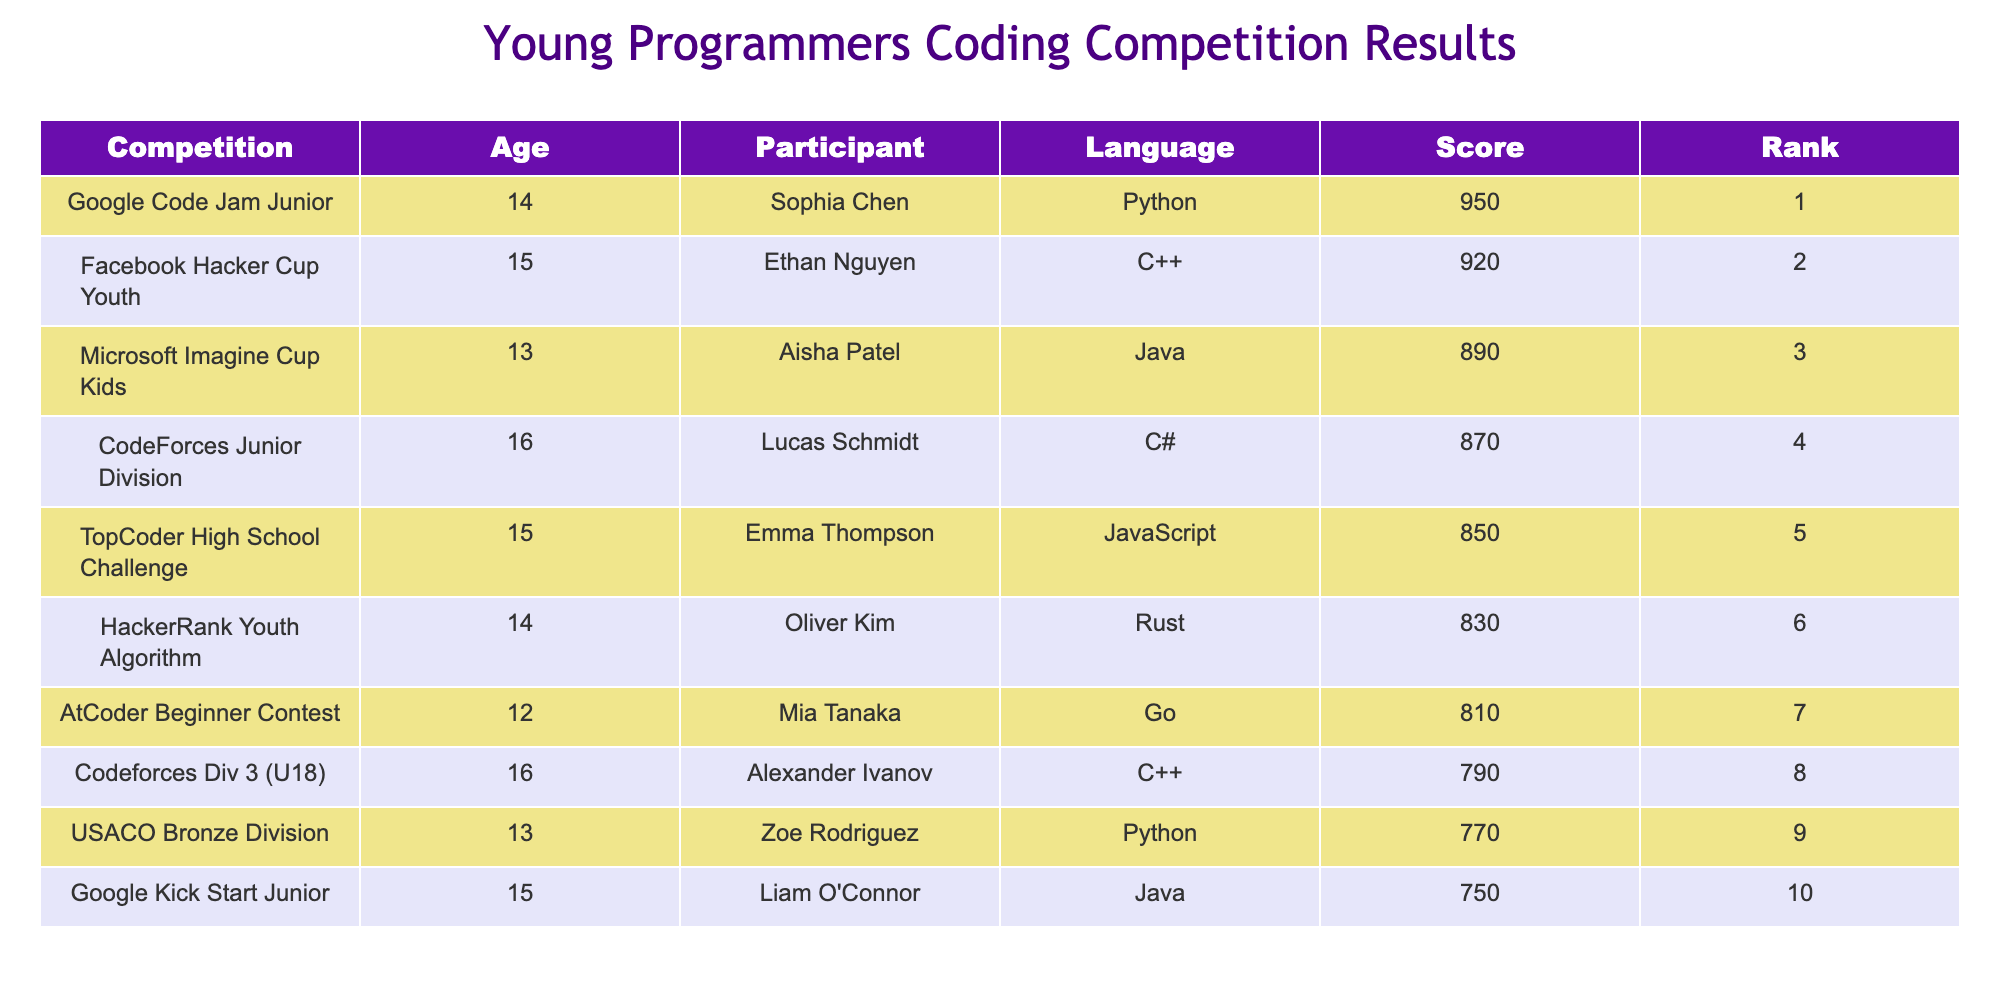What is the highest score achieved in the competition? The table lists the scores for each participant. The highest score is found in the first row with Sophia Chen scoring 950.
Answer: 950 Which programming language did Lucas Schmidt use? Lucas Schmidt is listed in the fourth row with a score of 870 and the language specified is C#.
Answer: C# How many participants scored above 800? By examining the scores in the table, the participants with scores above 800 are Sophia (950), Ethan (920), Aisha (890), Lucas (870), Oliver (830), and Mia (810). This makes a total of 6 participants.
Answer: 6 What is the average score of participants aged 15? The participants aged 15 are Ethan (920), Emma (850), and Liam (750). The sum of their scores is 920 + 850 + 750 = 2520, and since there are 3 participants, the average is 2520 / 3 = 840.
Answer: 840 Did any participant score below 800? By scanning the scores listed in the table, Alexander Ivanov (790) and Zoe Rodriguez (770) both scored below 800. Therefore, the answer is yes.
Answer: Yes Who ranked fourth in the competition? The table shows that Lucas Schmidt is in the fourth row with a rank of 4.
Answer: Lucas Schmidt Which participant had the lowest score, and what was their score? The table reveals that Zoe Rodriguez scored 770, which is the lowest score listed among the participants.
Answer: Zoe Rodriguez, 770 What is the difference in score between the first and last ranked participants? The first-ranked participant is Sophia Chen with a score of 950, and the last ranked is Zoe Rodriguez with a score of 770. The difference is calculated as 950 - 770 = 180.
Answer: 180 Is there a participant aged 12 who scored over 800? Mia Tanaka is the only participant aged 12, and her score is 810, which is indeed over 800. Thus, the answer is yes.
Answer: Yes 